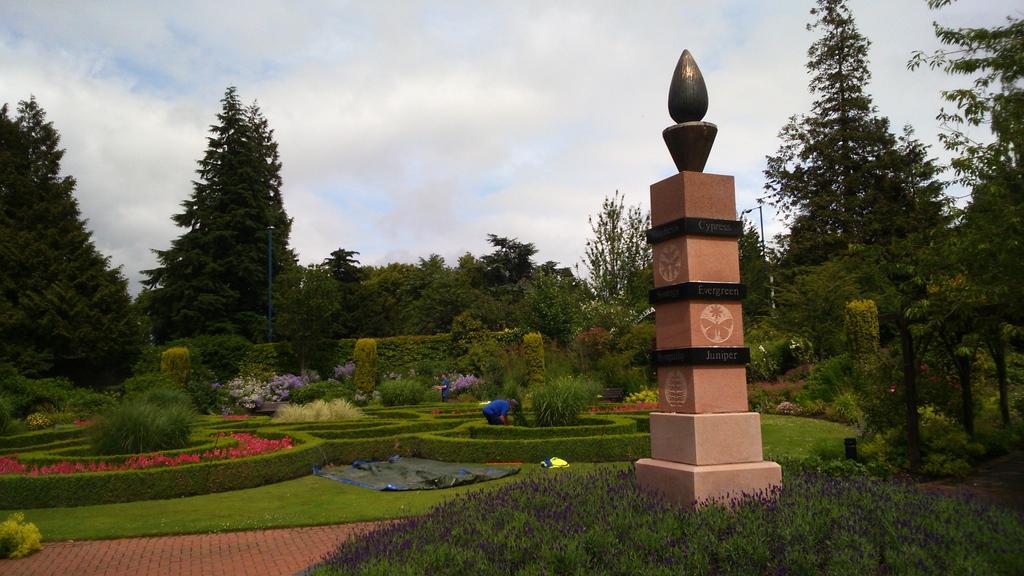Could you give a brief overview of what you see in this image? In this picture I can see I can see green grass. I can see the walkway. I can see people. I can see flower plants. I can see trees. I can see memorial on the right side. I can see clouds in the sky. 